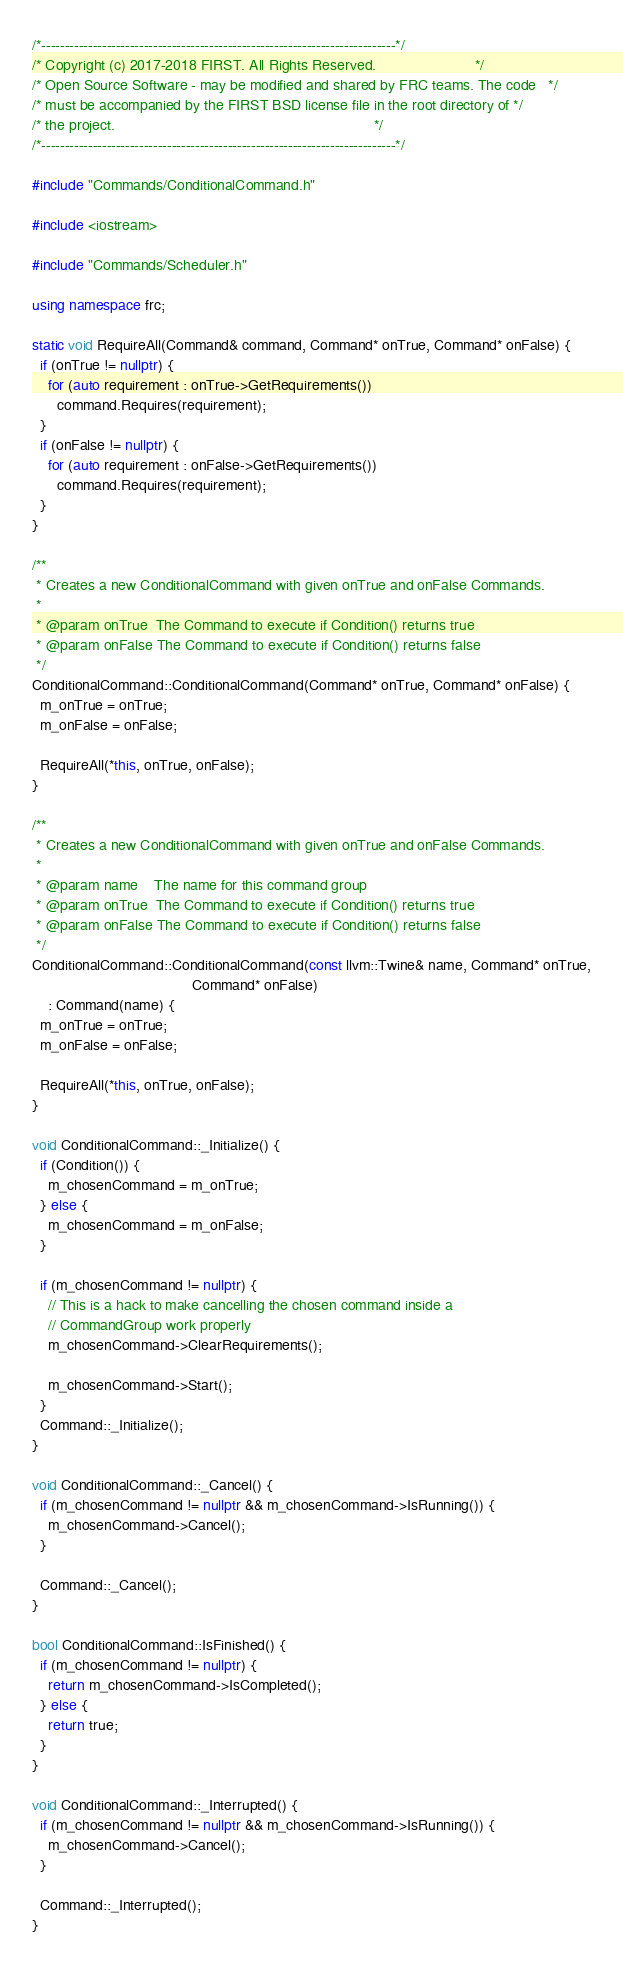<code> <loc_0><loc_0><loc_500><loc_500><_C++_>/*----------------------------------------------------------------------------*/
/* Copyright (c) 2017-2018 FIRST. All Rights Reserved.                        */
/* Open Source Software - may be modified and shared by FRC teams. The code   */
/* must be accompanied by the FIRST BSD license file in the root directory of */
/* the project.                                                               */
/*----------------------------------------------------------------------------*/

#include "Commands/ConditionalCommand.h"

#include <iostream>

#include "Commands/Scheduler.h"

using namespace frc;

static void RequireAll(Command& command, Command* onTrue, Command* onFalse) {
  if (onTrue != nullptr) {
    for (auto requirement : onTrue->GetRequirements())
      command.Requires(requirement);
  }
  if (onFalse != nullptr) {
    for (auto requirement : onFalse->GetRequirements())
      command.Requires(requirement);
  }
}

/**
 * Creates a new ConditionalCommand with given onTrue and onFalse Commands.
 *
 * @param onTrue  The Command to execute if Condition() returns true
 * @param onFalse The Command to execute if Condition() returns false
 */
ConditionalCommand::ConditionalCommand(Command* onTrue, Command* onFalse) {
  m_onTrue = onTrue;
  m_onFalse = onFalse;

  RequireAll(*this, onTrue, onFalse);
}

/**
 * Creates a new ConditionalCommand with given onTrue and onFalse Commands.
 *
 * @param name    The name for this command group
 * @param onTrue  The Command to execute if Condition() returns true
 * @param onFalse The Command to execute if Condition() returns false
 */
ConditionalCommand::ConditionalCommand(const llvm::Twine& name, Command* onTrue,
                                       Command* onFalse)
    : Command(name) {
  m_onTrue = onTrue;
  m_onFalse = onFalse;

  RequireAll(*this, onTrue, onFalse);
}

void ConditionalCommand::_Initialize() {
  if (Condition()) {
    m_chosenCommand = m_onTrue;
  } else {
    m_chosenCommand = m_onFalse;
  }

  if (m_chosenCommand != nullptr) {
    // This is a hack to make cancelling the chosen command inside a
    // CommandGroup work properly
    m_chosenCommand->ClearRequirements();

    m_chosenCommand->Start();
  }
  Command::_Initialize();
}

void ConditionalCommand::_Cancel() {
  if (m_chosenCommand != nullptr && m_chosenCommand->IsRunning()) {
    m_chosenCommand->Cancel();
  }

  Command::_Cancel();
}

bool ConditionalCommand::IsFinished() {
  if (m_chosenCommand != nullptr) {
    return m_chosenCommand->IsCompleted();
  } else {
    return true;
  }
}

void ConditionalCommand::_Interrupted() {
  if (m_chosenCommand != nullptr && m_chosenCommand->IsRunning()) {
    m_chosenCommand->Cancel();
  }

  Command::_Interrupted();
}
</code> 